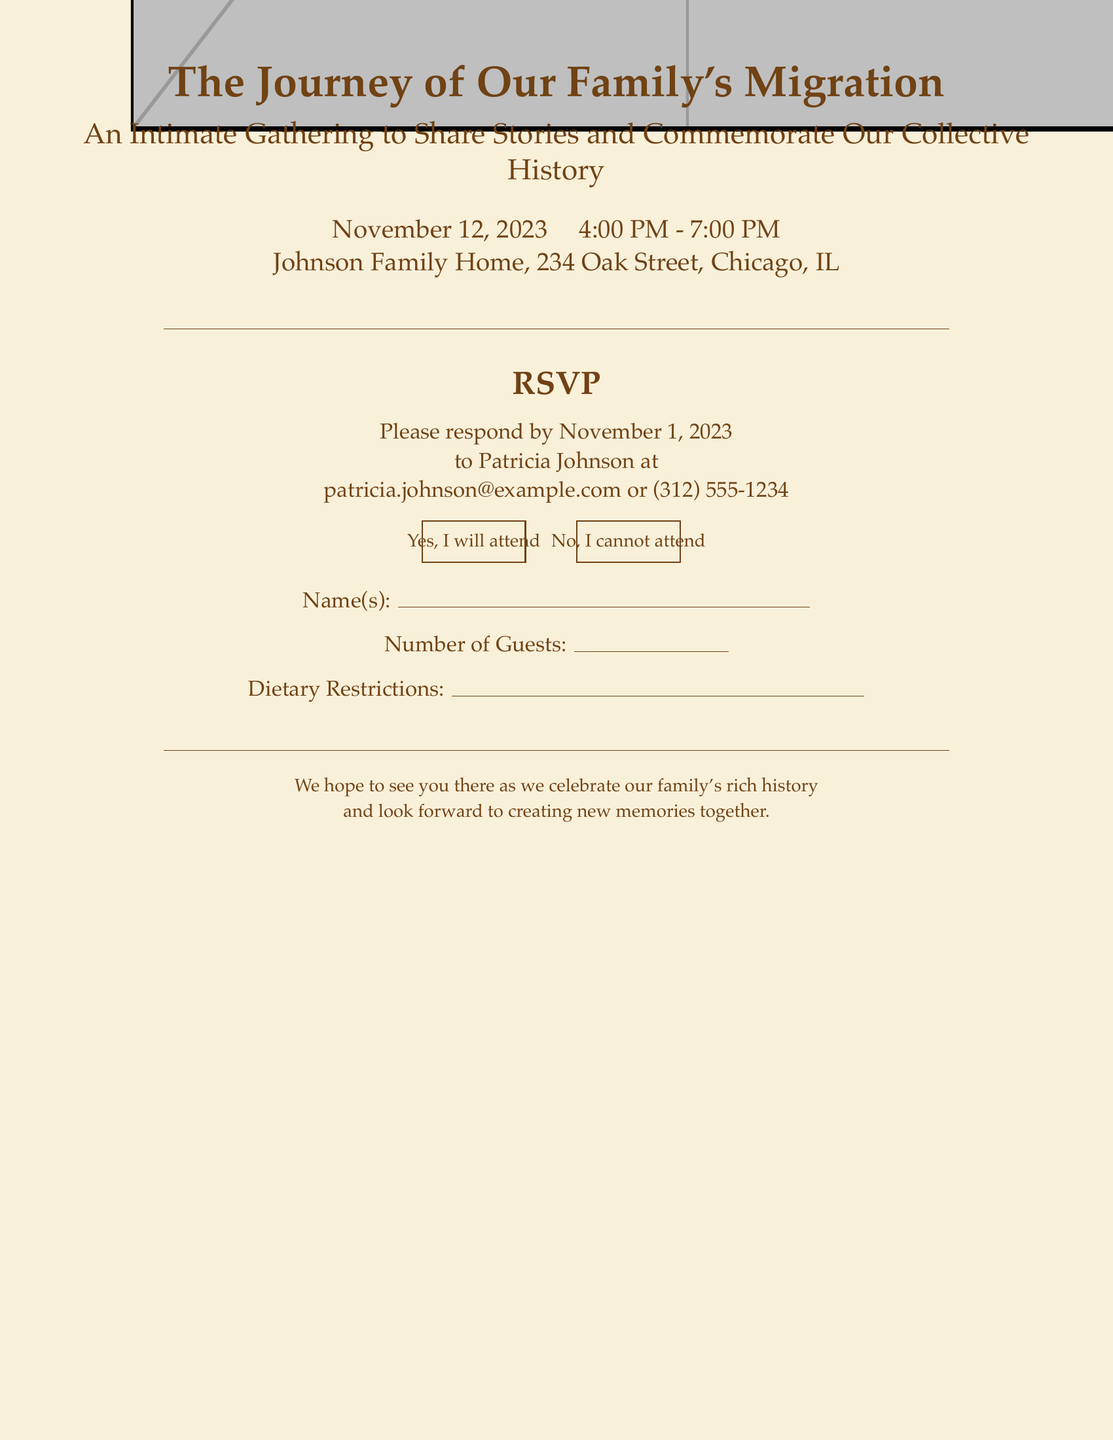What is the date of the gathering? The date of the gathering is specified in the document as November 12, 2023.
Answer: November 12, 2023 What time does the gathering start? The start time is mentioned in the document as 4:00 PM.
Answer: 4:00 PM Where is the gathering taking place? The document provides the location of the gathering, which is the Johnson Family Home at 234 Oak Street, Chicago, IL.
Answer: Johnson Family Home, 234 Oak Street, Chicago, IL Who should the attendees contact for RSVP? The document states that attendees should respond to Patricia Johnson.
Answer: Patricia Johnson What is the RSVP deadline date? The RSVP deadline is clearly mentioned in the document as November 1, 2023.
Answer: November 1, 2023 What are the two options provided for RSVP? The document lists options for RSVPing, which are "Yes, I will attend" and "No, I cannot attend".
Answer: Yes, I will attend; No, I cannot attend How many guests can attendees report? The document has a space for the number of guests, indicating that attendees can report their guests.
Answer: Number of Guests: (open space) What is the purpose of the gathering? The document outlines the purpose of the gathering as sharing stories and commemorating collective history.
Answer: Share stories and commemorate our collective history What is the requested information regarding dietary needs? The document includes an area asking for dietary restrictions.
Answer: Dietary Restrictions: (open space) 